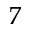<formula> <loc_0><loc_0><loc_500><loc_500>^ { 7 }</formula> 